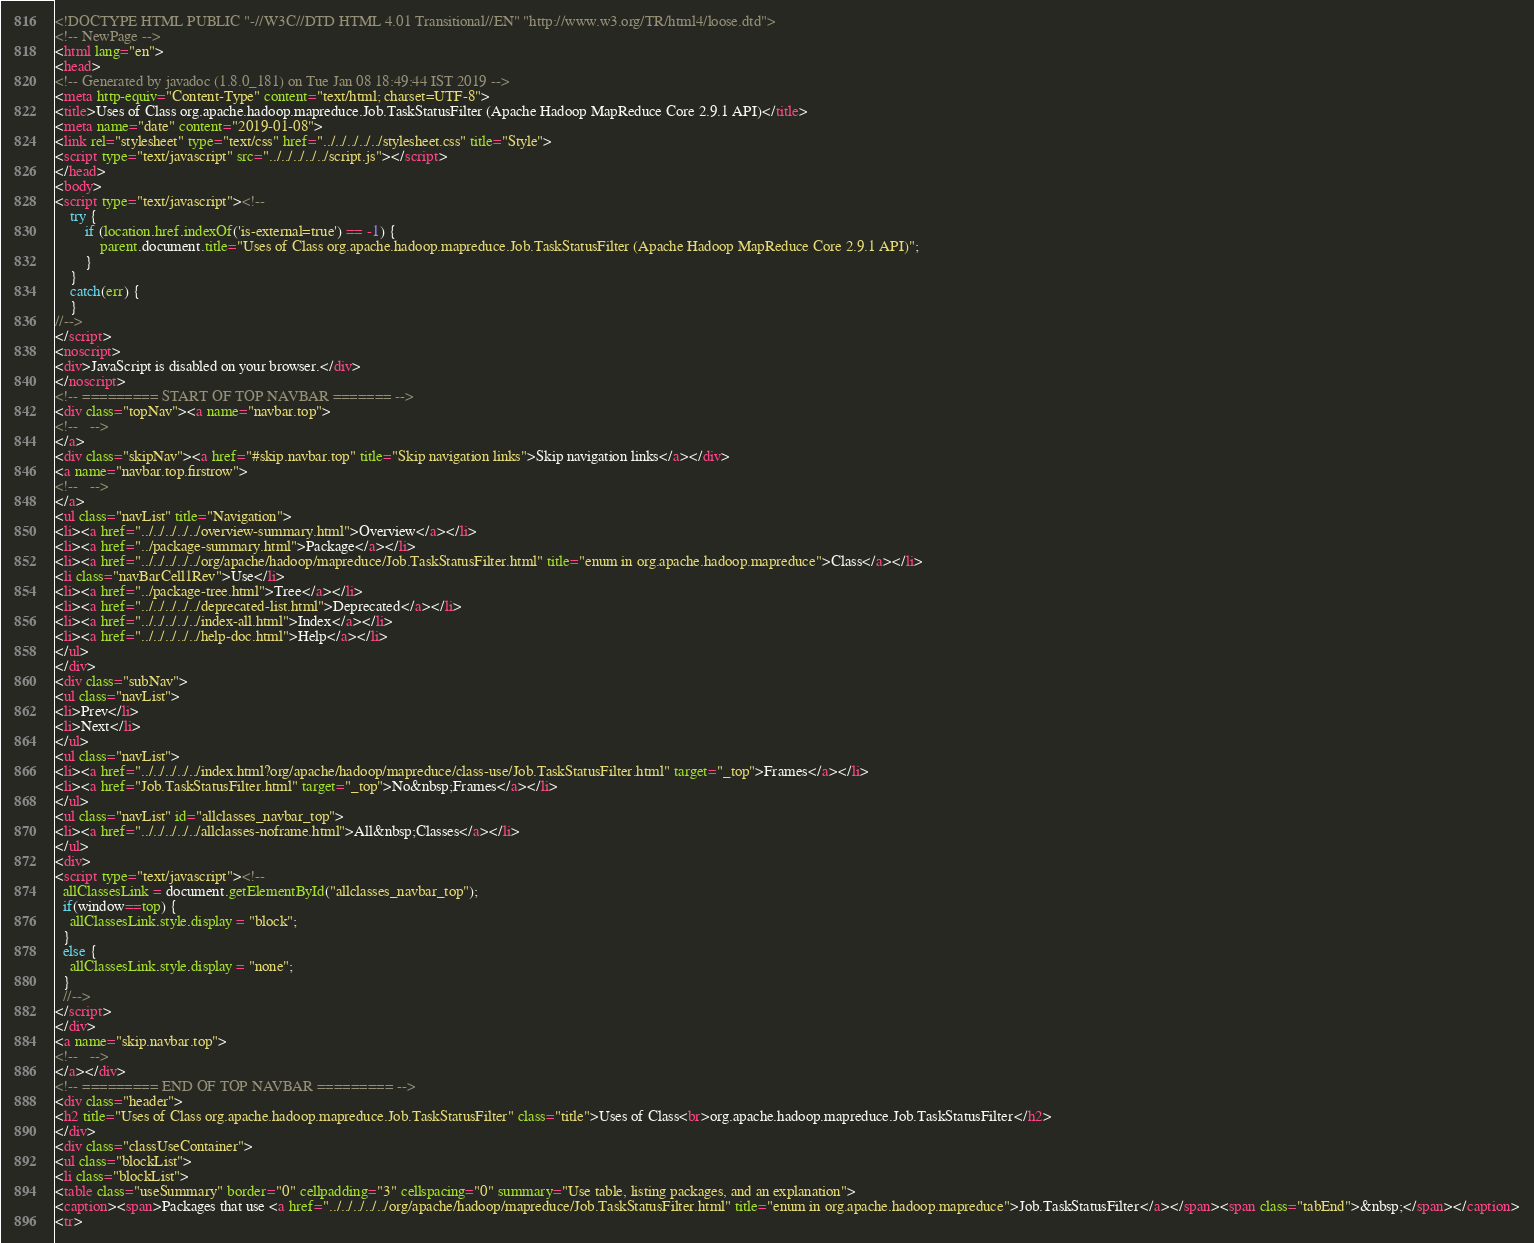<code> <loc_0><loc_0><loc_500><loc_500><_HTML_><!DOCTYPE HTML PUBLIC "-//W3C//DTD HTML 4.01 Transitional//EN" "http://www.w3.org/TR/html4/loose.dtd">
<!-- NewPage -->
<html lang="en">
<head>
<!-- Generated by javadoc (1.8.0_181) on Tue Jan 08 18:49:44 IST 2019 -->
<meta http-equiv="Content-Type" content="text/html; charset=UTF-8">
<title>Uses of Class org.apache.hadoop.mapreduce.Job.TaskStatusFilter (Apache Hadoop MapReduce Core 2.9.1 API)</title>
<meta name="date" content="2019-01-08">
<link rel="stylesheet" type="text/css" href="../../../../../stylesheet.css" title="Style">
<script type="text/javascript" src="../../../../../script.js"></script>
</head>
<body>
<script type="text/javascript"><!--
    try {
        if (location.href.indexOf('is-external=true') == -1) {
            parent.document.title="Uses of Class org.apache.hadoop.mapreduce.Job.TaskStatusFilter (Apache Hadoop MapReduce Core 2.9.1 API)";
        }
    }
    catch(err) {
    }
//-->
</script>
<noscript>
<div>JavaScript is disabled on your browser.</div>
</noscript>
<!-- ========= START OF TOP NAVBAR ======= -->
<div class="topNav"><a name="navbar.top">
<!--   -->
</a>
<div class="skipNav"><a href="#skip.navbar.top" title="Skip navigation links">Skip navigation links</a></div>
<a name="navbar.top.firstrow">
<!--   -->
</a>
<ul class="navList" title="Navigation">
<li><a href="../../../../../overview-summary.html">Overview</a></li>
<li><a href="../package-summary.html">Package</a></li>
<li><a href="../../../../../org/apache/hadoop/mapreduce/Job.TaskStatusFilter.html" title="enum in org.apache.hadoop.mapreduce">Class</a></li>
<li class="navBarCell1Rev">Use</li>
<li><a href="../package-tree.html">Tree</a></li>
<li><a href="../../../../../deprecated-list.html">Deprecated</a></li>
<li><a href="../../../../../index-all.html">Index</a></li>
<li><a href="../../../../../help-doc.html">Help</a></li>
</ul>
</div>
<div class="subNav">
<ul class="navList">
<li>Prev</li>
<li>Next</li>
</ul>
<ul class="navList">
<li><a href="../../../../../index.html?org/apache/hadoop/mapreduce/class-use/Job.TaskStatusFilter.html" target="_top">Frames</a></li>
<li><a href="Job.TaskStatusFilter.html" target="_top">No&nbsp;Frames</a></li>
</ul>
<ul class="navList" id="allclasses_navbar_top">
<li><a href="../../../../../allclasses-noframe.html">All&nbsp;Classes</a></li>
</ul>
<div>
<script type="text/javascript"><!--
  allClassesLink = document.getElementById("allclasses_navbar_top");
  if(window==top) {
    allClassesLink.style.display = "block";
  }
  else {
    allClassesLink.style.display = "none";
  }
  //-->
</script>
</div>
<a name="skip.navbar.top">
<!--   -->
</a></div>
<!-- ========= END OF TOP NAVBAR ========= -->
<div class="header">
<h2 title="Uses of Class org.apache.hadoop.mapreduce.Job.TaskStatusFilter" class="title">Uses of Class<br>org.apache.hadoop.mapreduce.Job.TaskStatusFilter</h2>
</div>
<div class="classUseContainer">
<ul class="blockList">
<li class="blockList">
<table class="useSummary" border="0" cellpadding="3" cellspacing="0" summary="Use table, listing packages, and an explanation">
<caption><span>Packages that use <a href="../../../../../org/apache/hadoop/mapreduce/Job.TaskStatusFilter.html" title="enum in org.apache.hadoop.mapreduce">Job.TaskStatusFilter</a></span><span class="tabEnd">&nbsp;</span></caption>
<tr></code> 